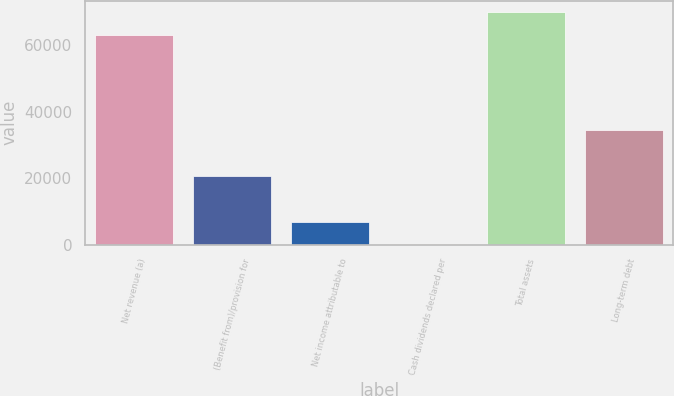<chart> <loc_0><loc_0><loc_500><loc_500><bar_chart><fcel>Net revenue (a)<fcel>(Benefit from)/provision for<fcel>Net income attributable to<fcel>Cash dividends declared per<fcel>Total assets<fcel>Long-term debt<nl><fcel>63056<fcel>20694.7<fcel>6900.08<fcel>2.76<fcel>69953.3<fcel>34489.4<nl></chart> 